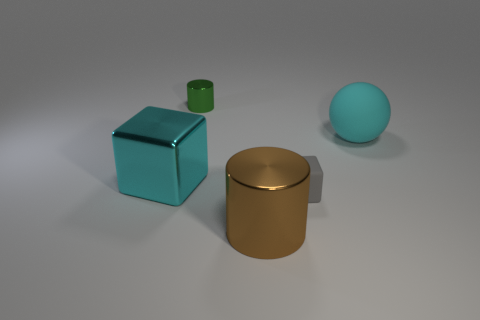Is there any other thing that has the same material as the brown thing?
Your answer should be very brief. Yes. Are there more large brown metal objects on the left side of the rubber block than small red cylinders?
Keep it short and to the point. Yes. What is the color of the small shiny cylinder?
Offer a terse response. Green. There is a large object that is behind the cyan thing that is on the left side of the rubber thing that is behind the small gray thing; what is its shape?
Offer a very short reply. Sphere. There is a large object that is both right of the green object and in front of the big matte sphere; what is its material?
Your answer should be compact. Metal. What is the shape of the small thing to the right of the metallic cylinder that is on the right side of the small green object?
Keep it short and to the point. Cube. Is there anything else of the same color as the tiny metallic object?
Your answer should be compact. No. There is a ball; does it have the same size as the metal cylinder behind the gray matte cube?
Your response must be concise. No. What number of tiny objects are yellow metal objects or shiny things?
Your answer should be very brief. 1. Are there more cyan rubber cylinders than rubber things?
Offer a terse response. No. 